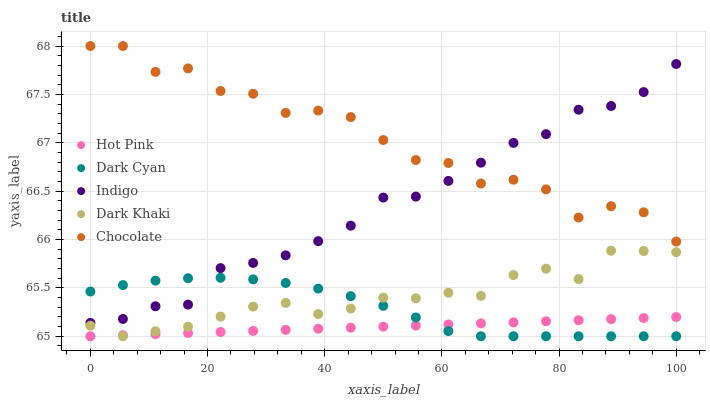Does Hot Pink have the minimum area under the curve?
Answer yes or no. Yes. Does Chocolate have the maximum area under the curve?
Answer yes or no. Yes. Does Dark Khaki have the minimum area under the curve?
Answer yes or no. No. Does Dark Khaki have the maximum area under the curve?
Answer yes or no. No. Is Hot Pink the smoothest?
Answer yes or no. Yes. Is Chocolate the roughest?
Answer yes or no. Yes. Is Dark Khaki the smoothest?
Answer yes or no. No. Is Dark Khaki the roughest?
Answer yes or no. No. Does Dark Cyan have the lowest value?
Answer yes or no. Yes. Does Indigo have the lowest value?
Answer yes or no. No. Does Chocolate have the highest value?
Answer yes or no. Yes. Does Dark Khaki have the highest value?
Answer yes or no. No. Is Dark Cyan less than Chocolate?
Answer yes or no. Yes. Is Indigo greater than Hot Pink?
Answer yes or no. Yes. Does Hot Pink intersect Dark Cyan?
Answer yes or no. Yes. Is Hot Pink less than Dark Cyan?
Answer yes or no. No. Is Hot Pink greater than Dark Cyan?
Answer yes or no. No. Does Dark Cyan intersect Chocolate?
Answer yes or no. No. 